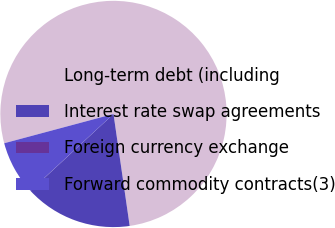Convert chart. <chart><loc_0><loc_0><loc_500><loc_500><pie_chart><fcel>Long-term debt (including<fcel>Interest rate swap agreements<fcel>Foreign currency exchange<fcel>Forward commodity contracts(3)<nl><fcel>76.88%<fcel>15.39%<fcel>0.02%<fcel>7.71%<nl></chart> 